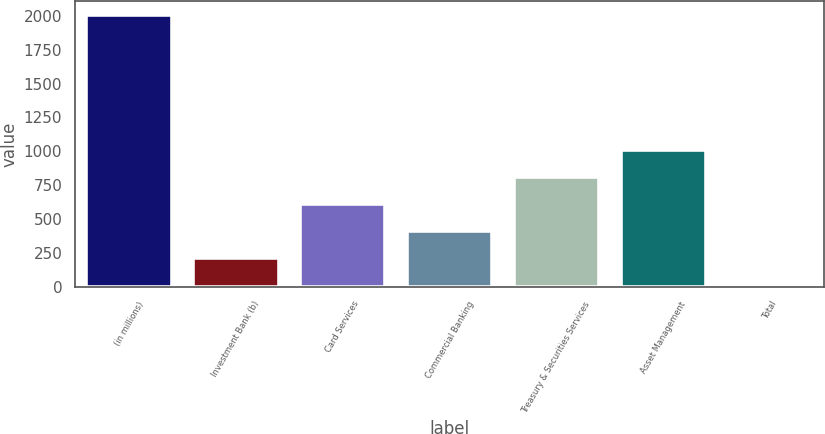Convert chart to OTSL. <chart><loc_0><loc_0><loc_500><loc_500><bar_chart><fcel>(in millions)<fcel>Investment Bank (b)<fcel>Card Services<fcel>Commercial Banking<fcel>Treasury & Securities Services<fcel>Asset Management<fcel>Total<nl><fcel>2007<fcel>212.4<fcel>611.2<fcel>411.8<fcel>810.6<fcel>1010<fcel>13<nl></chart> 